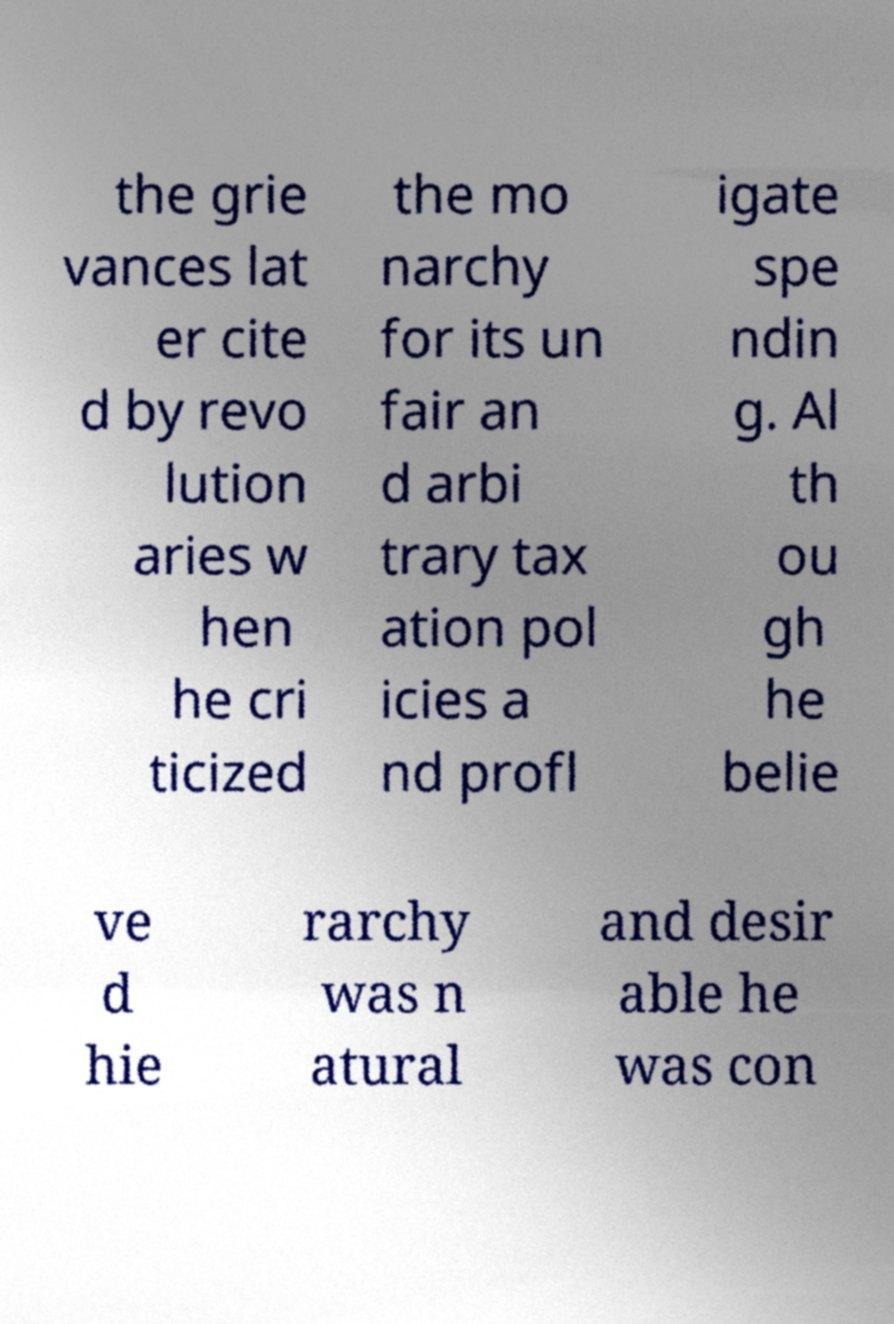There's text embedded in this image that I need extracted. Can you transcribe it verbatim? the grie vances lat er cite d by revo lution aries w hen he cri ticized the mo narchy for its un fair an d arbi trary tax ation pol icies a nd profl igate spe ndin g. Al th ou gh he belie ve d hie rarchy was n atural and desir able he was con 